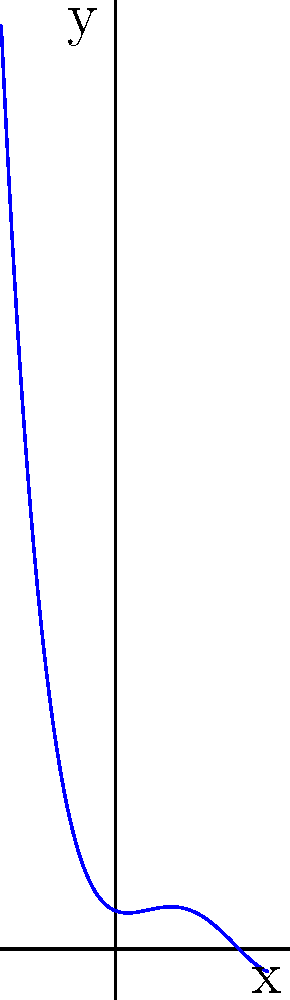As an aspiring actor, you're studying the curve of a character's emotional arc throughout a play. The playwright describes the emotional journey using a polynomial function, represented by the graph above. Based on the shape of the curve, what is the degree of this polynomial function? To determine the degree of a polynomial based on its graph, we need to consider the following steps:

1. Count the number of turning points (local maxima and minima):
   The graph shows 3 turning points.

2. Consider the behavior at the ends of the graph:
   Both ends of the graph seem to go upward (positive infinity).

3. Apply the rule: The degree of a polynomial is at most one more than the number of turning points.
   Since we have 3 turning points, the maximum degree could be 4.

4. Check if the end behavior matches a 4th-degree polynomial:
   For an even-degree polynomial, both ends should point in the same direction (up or down).
   In this case, both ends point upward, which is consistent with a 4th-degree polynomial.

5. Confirm that a lower degree wouldn't fit:
   A 3rd-degree polynomial would have at most 2 turning points and opposite end behaviors.
   This graph has 3 turning points and same-direction end behaviors.

Therefore, the degree of this polynomial must be 4.
Answer: 4 